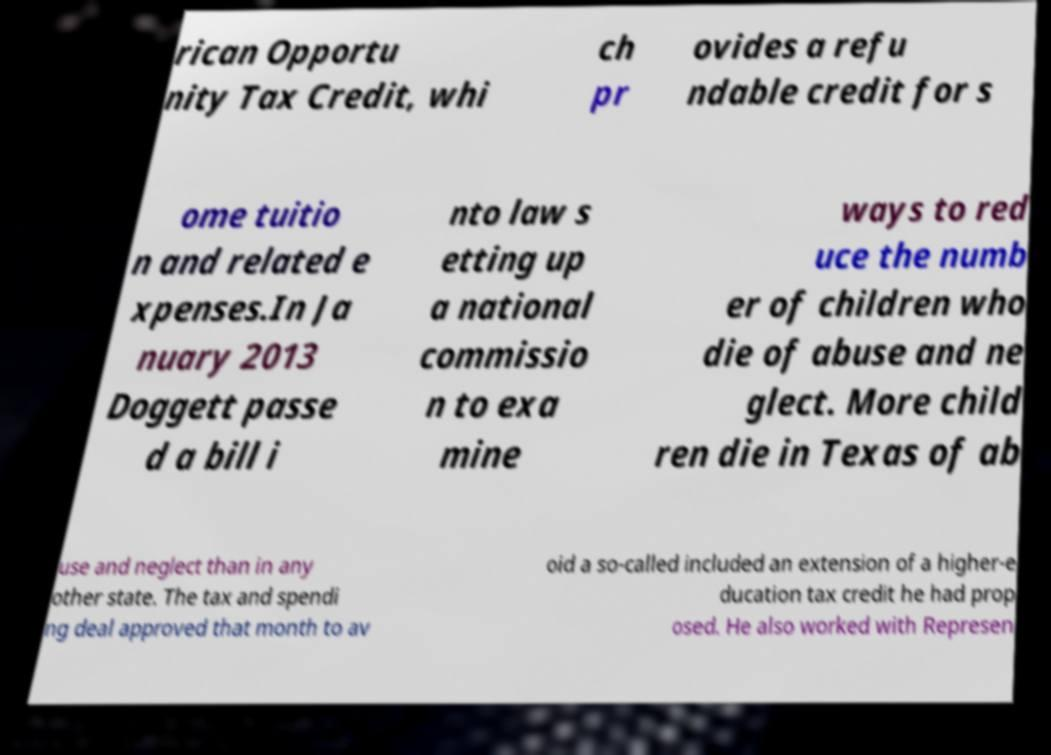Could you assist in decoding the text presented in this image and type it out clearly? rican Opportu nity Tax Credit, whi ch pr ovides a refu ndable credit for s ome tuitio n and related e xpenses.In Ja nuary 2013 Doggett passe d a bill i nto law s etting up a national commissio n to exa mine ways to red uce the numb er of children who die of abuse and ne glect. More child ren die in Texas of ab use and neglect than in any other state. The tax and spendi ng deal approved that month to av oid a so-called included an extension of a higher-e ducation tax credit he had prop osed. He also worked with Represen 